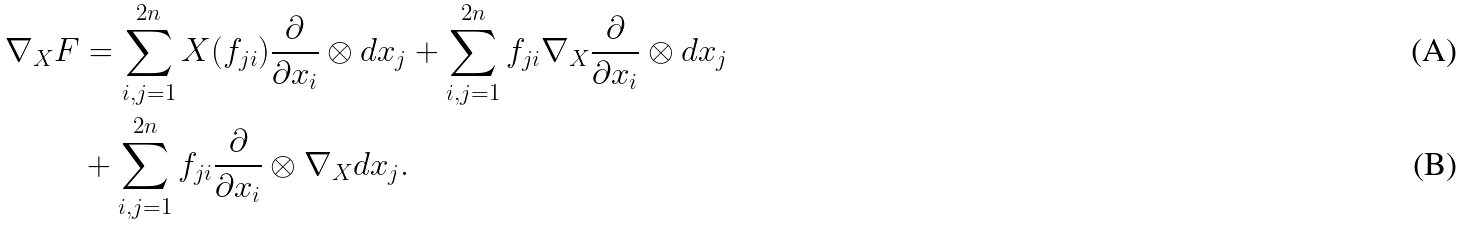Convert formula to latex. <formula><loc_0><loc_0><loc_500><loc_500>\nabla _ { X } F & = \sum _ { i , j = 1 } ^ { 2 n } X ( f _ { j i } ) \frac { \partial } { \partial x _ { i } } \otimes d x _ { j } + \sum _ { i , j = 1 } ^ { 2 n } f _ { j i } \nabla _ { X } \frac { \partial } { \partial x _ { i } } \otimes d x _ { j } \\ & + \sum _ { i , j = 1 } ^ { 2 n } f _ { j i } \frac { \partial } { \partial x _ { i } } \otimes \nabla _ { X } d x _ { j } .</formula> 